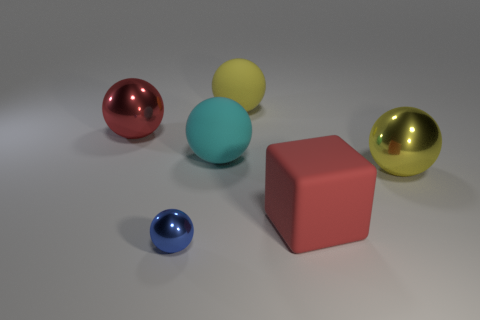There is a metal object that is left of the large rubber cube and behind the blue metal thing; what is its color?
Ensure brevity in your answer.  Red. Are there more red spheres that are to the right of the cyan rubber object than yellow balls in front of the big yellow rubber thing?
Your response must be concise. No. What is the color of the large shiny sphere on the right side of the small sphere?
Provide a short and direct response. Yellow. Do the large red thing that is behind the rubber block and the yellow object in front of the big cyan sphere have the same shape?
Offer a very short reply. Yes. Is there a yellow matte thing of the same size as the cube?
Give a very brief answer. Yes. There is a large cyan thing that is to the left of the yellow matte object; what is its material?
Give a very brief answer. Rubber. Is the large object on the right side of the big matte cube made of the same material as the large red ball?
Give a very brief answer. Yes. Is there a tiny purple sphere?
Give a very brief answer. No. There is another large sphere that is made of the same material as the large cyan ball; what color is it?
Keep it short and to the point. Yellow. There is a thing that is in front of the big red thing that is in front of the big metallic thing that is behind the cyan matte sphere; what is its color?
Make the answer very short. Blue. 